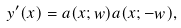Convert formula to latex. <formula><loc_0><loc_0><loc_500><loc_500>y ^ { \prime } ( x ) = a ( x ; w ) a ( x ; - w ) ,</formula> 